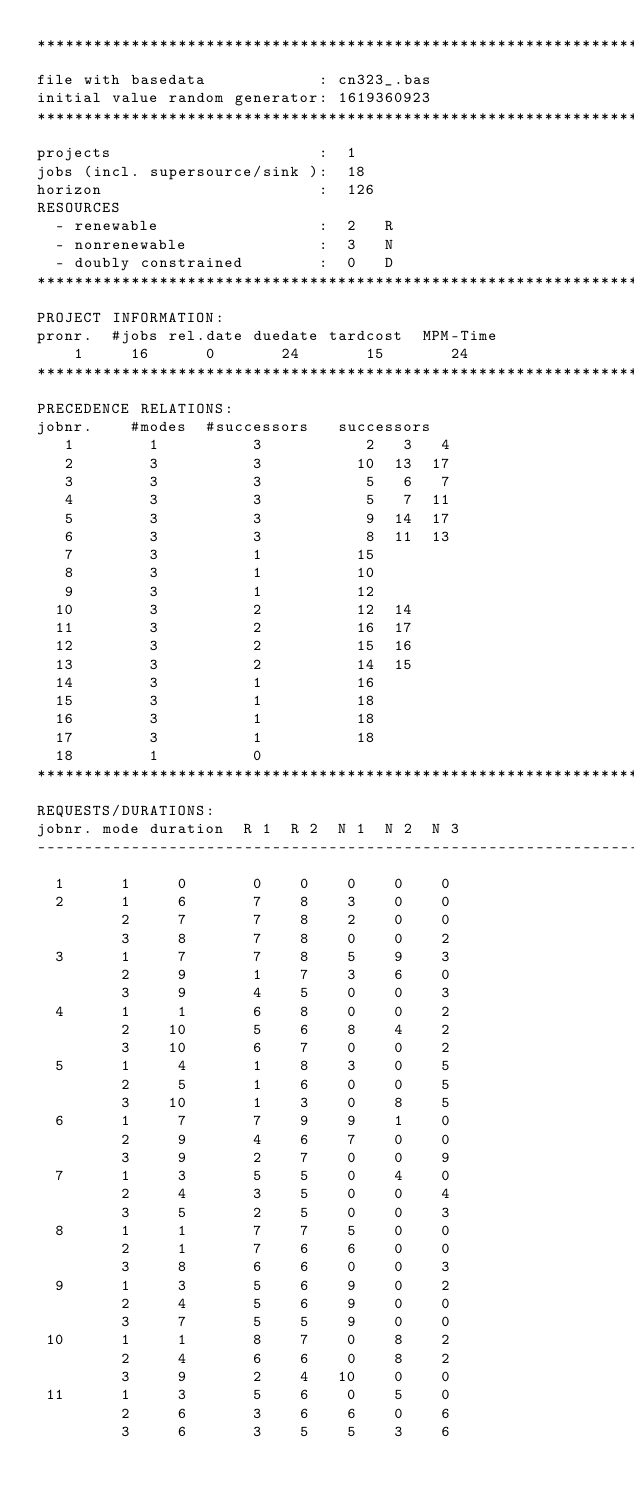<code> <loc_0><loc_0><loc_500><loc_500><_ObjectiveC_>************************************************************************
file with basedata            : cn323_.bas
initial value random generator: 1619360923
************************************************************************
projects                      :  1
jobs (incl. supersource/sink ):  18
horizon                       :  126
RESOURCES
  - renewable                 :  2   R
  - nonrenewable              :  3   N
  - doubly constrained        :  0   D
************************************************************************
PROJECT INFORMATION:
pronr.  #jobs rel.date duedate tardcost  MPM-Time
    1     16      0       24       15       24
************************************************************************
PRECEDENCE RELATIONS:
jobnr.    #modes  #successors   successors
   1        1          3           2   3   4
   2        3          3          10  13  17
   3        3          3           5   6   7
   4        3          3           5   7  11
   5        3          3           9  14  17
   6        3          3           8  11  13
   7        3          1          15
   8        3          1          10
   9        3          1          12
  10        3          2          12  14
  11        3          2          16  17
  12        3          2          15  16
  13        3          2          14  15
  14        3          1          16
  15        3          1          18
  16        3          1          18
  17        3          1          18
  18        1          0        
************************************************************************
REQUESTS/DURATIONS:
jobnr. mode duration  R 1  R 2  N 1  N 2  N 3
------------------------------------------------------------------------
  1      1     0       0    0    0    0    0
  2      1     6       7    8    3    0    0
         2     7       7    8    2    0    0
         3     8       7    8    0    0    2
  3      1     7       7    8    5    9    3
         2     9       1    7    3    6    0
         3     9       4    5    0    0    3
  4      1     1       6    8    0    0    2
         2    10       5    6    8    4    2
         3    10       6    7    0    0    2
  5      1     4       1    8    3    0    5
         2     5       1    6    0    0    5
         3    10       1    3    0    8    5
  6      1     7       7    9    9    1    0
         2     9       4    6    7    0    0
         3     9       2    7    0    0    9
  7      1     3       5    5    0    4    0
         2     4       3    5    0    0    4
         3     5       2    5    0    0    3
  8      1     1       7    7    5    0    0
         2     1       7    6    6    0    0
         3     8       6    6    0    0    3
  9      1     3       5    6    9    0    2
         2     4       5    6    9    0    0
         3     7       5    5    9    0    0
 10      1     1       8    7    0    8    2
         2     4       6    6    0    8    2
         3     9       2    4   10    0    0
 11      1     3       5    6    0    5    0
         2     6       3    6    6    0    6
         3     6       3    5    5    3    6</code> 